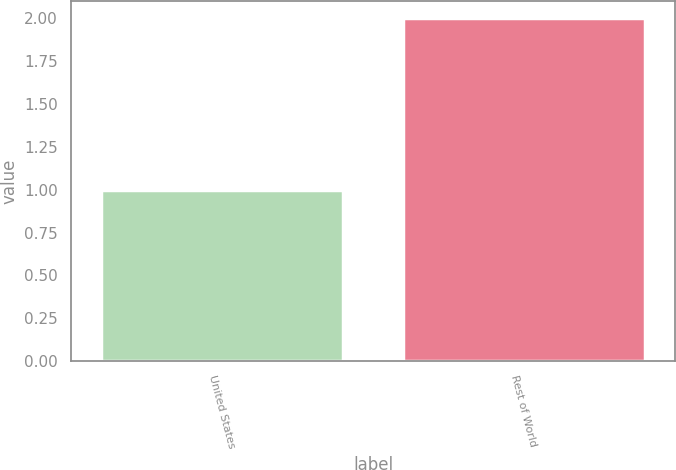Convert chart. <chart><loc_0><loc_0><loc_500><loc_500><bar_chart><fcel>United States<fcel>Rest of World<nl><fcel>1<fcel>2<nl></chart> 